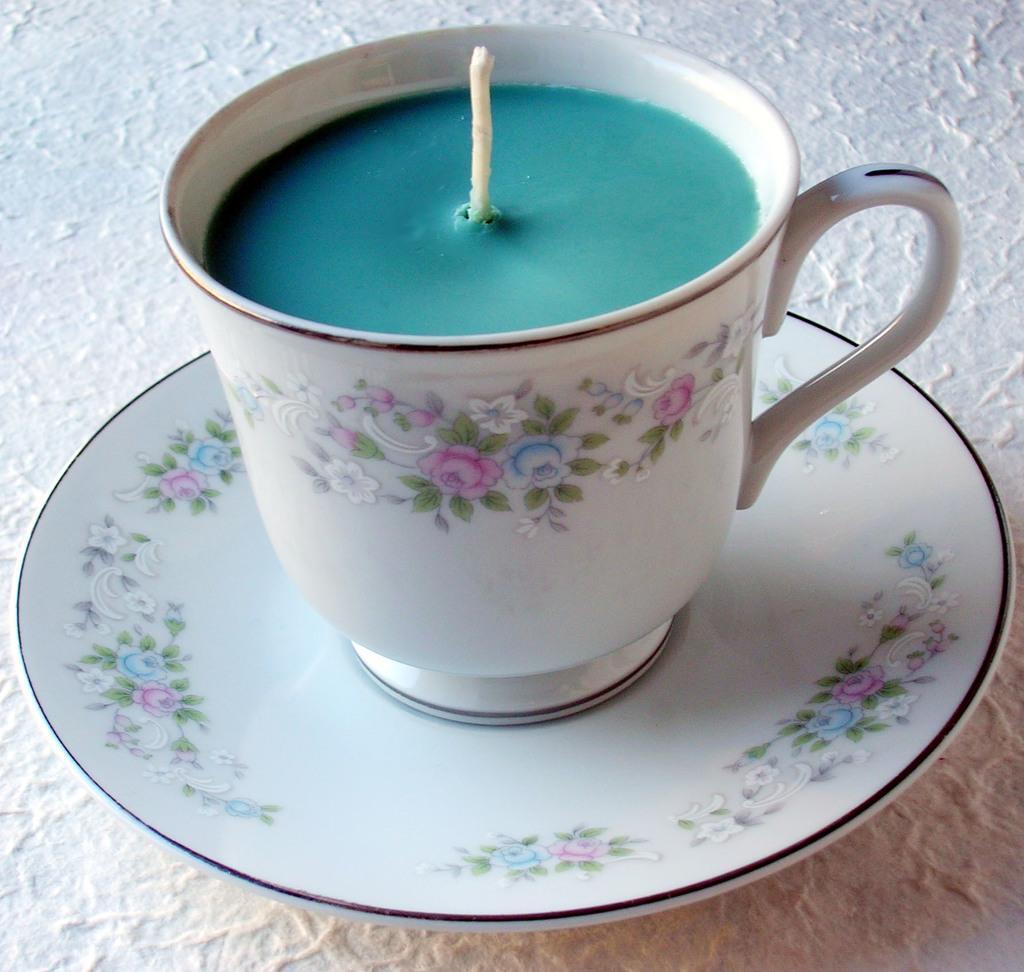In one or two sentences, can you explain what this image depicts? It is the candle wax in blue color in the white color cup and a saucer. 